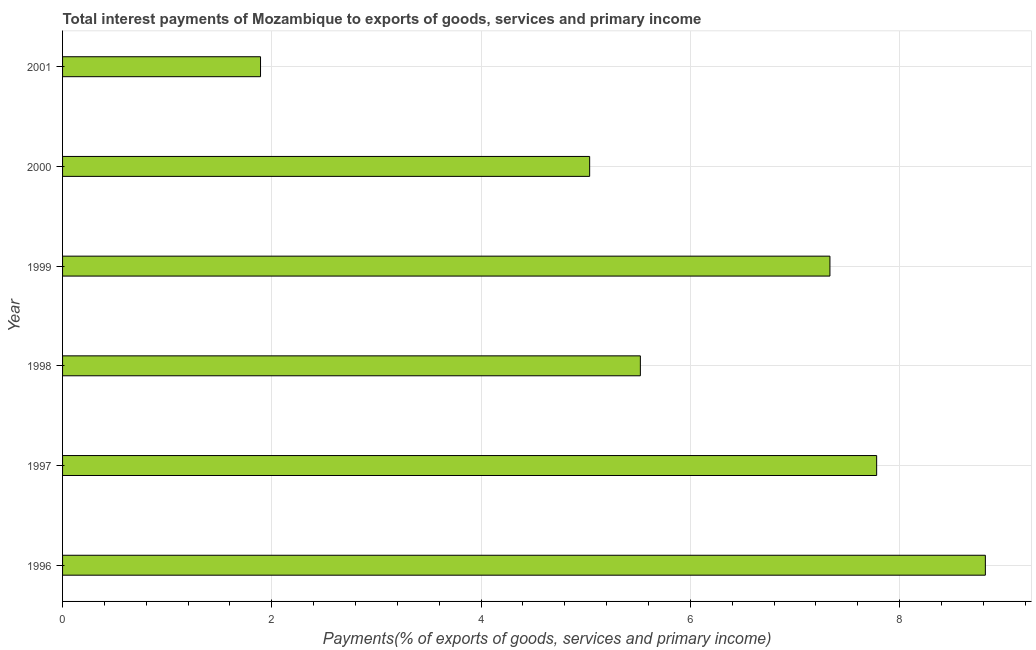Does the graph contain any zero values?
Offer a terse response. No. Does the graph contain grids?
Your answer should be compact. Yes. What is the title of the graph?
Offer a very short reply. Total interest payments of Mozambique to exports of goods, services and primary income. What is the label or title of the X-axis?
Offer a very short reply. Payments(% of exports of goods, services and primary income). What is the label or title of the Y-axis?
Make the answer very short. Year. What is the total interest payments on external debt in 2000?
Offer a terse response. 5.04. Across all years, what is the maximum total interest payments on external debt?
Your response must be concise. 8.82. Across all years, what is the minimum total interest payments on external debt?
Offer a terse response. 1.89. In which year was the total interest payments on external debt minimum?
Make the answer very short. 2001. What is the sum of the total interest payments on external debt?
Offer a very short reply. 36.38. What is the difference between the total interest payments on external debt in 1999 and 2000?
Give a very brief answer. 2.3. What is the average total interest payments on external debt per year?
Ensure brevity in your answer.  6.06. What is the median total interest payments on external debt?
Keep it short and to the point. 6.43. What is the ratio of the total interest payments on external debt in 2000 to that in 2001?
Keep it short and to the point. 2.66. Is the total interest payments on external debt in 1996 less than that in 2000?
Keep it short and to the point. No. What is the difference between the highest and the second highest total interest payments on external debt?
Offer a terse response. 1.04. Is the sum of the total interest payments on external debt in 1996 and 1997 greater than the maximum total interest payments on external debt across all years?
Provide a short and direct response. Yes. What is the difference between the highest and the lowest total interest payments on external debt?
Your response must be concise. 6.93. In how many years, is the total interest payments on external debt greater than the average total interest payments on external debt taken over all years?
Offer a terse response. 3. Are all the bars in the graph horizontal?
Your answer should be compact. Yes. What is the difference between two consecutive major ticks on the X-axis?
Your answer should be compact. 2. What is the Payments(% of exports of goods, services and primary income) of 1996?
Make the answer very short. 8.82. What is the Payments(% of exports of goods, services and primary income) of 1997?
Your answer should be compact. 7.78. What is the Payments(% of exports of goods, services and primary income) of 1998?
Offer a terse response. 5.52. What is the Payments(% of exports of goods, services and primary income) in 1999?
Make the answer very short. 7.33. What is the Payments(% of exports of goods, services and primary income) in 2000?
Your response must be concise. 5.04. What is the Payments(% of exports of goods, services and primary income) of 2001?
Make the answer very short. 1.89. What is the difference between the Payments(% of exports of goods, services and primary income) in 1996 and 1997?
Offer a very short reply. 1.04. What is the difference between the Payments(% of exports of goods, services and primary income) in 1996 and 1998?
Offer a terse response. 3.3. What is the difference between the Payments(% of exports of goods, services and primary income) in 1996 and 1999?
Your answer should be very brief. 1.49. What is the difference between the Payments(% of exports of goods, services and primary income) in 1996 and 2000?
Give a very brief answer. 3.78. What is the difference between the Payments(% of exports of goods, services and primary income) in 1996 and 2001?
Offer a very short reply. 6.93. What is the difference between the Payments(% of exports of goods, services and primary income) in 1997 and 1998?
Offer a terse response. 2.26. What is the difference between the Payments(% of exports of goods, services and primary income) in 1997 and 1999?
Make the answer very short. 0.45. What is the difference between the Payments(% of exports of goods, services and primary income) in 1997 and 2000?
Your answer should be very brief. 2.74. What is the difference between the Payments(% of exports of goods, services and primary income) in 1997 and 2001?
Your answer should be compact. 5.89. What is the difference between the Payments(% of exports of goods, services and primary income) in 1998 and 1999?
Offer a very short reply. -1.81. What is the difference between the Payments(% of exports of goods, services and primary income) in 1998 and 2000?
Ensure brevity in your answer.  0.48. What is the difference between the Payments(% of exports of goods, services and primary income) in 1998 and 2001?
Your answer should be compact. 3.63. What is the difference between the Payments(% of exports of goods, services and primary income) in 1999 and 2000?
Ensure brevity in your answer.  2.3. What is the difference between the Payments(% of exports of goods, services and primary income) in 1999 and 2001?
Your answer should be compact. 5.44. What is the difference between the Payments(% of exports of goods, services and primary income) in 2000 and 2001?
Offer a very short reply. 3.15. What is the ratio of the Payments(% of exports of goods, services and primary income) in 1996 to that in 1997?
Provide a short and direct response. 1.13. What is the ratio of the Payments(% of exports of goods, services and primary income) in 1996 to that in 1998?
Provide a short and direct response. 1.6. What is the ratio of the Payments(% of exports of goods, services and primary income) in 1996 to that in 1999?
Offer a terse response. 1.2. What is the ratio of the Payments(% of exports of goods, services and primary income) in 1996 to that in 2000?
Provide a short and direct response. 1.75. What is the ratio of the Payments(% of exports of goods, services and primary income) in 1996 to that in 2001?
Offer a very short reply. 4.66. What is the ratio of the Payments(% of exports of goods, services and primary income) in 1997 to that in 1998?
Offer a terse response. 1.41. What is the ratio of the Payments(% of exports of goods, services and primary income) in 1997 to that in 1999?
Make the answer very short. 1.06. What is the ratio of the Payments(% of exports of goods, services and primary income) in 1997 to that in 2000?
Give a very brief answer. 1.54. What is the ratio of the Payments(% of exports of goods, services and primary income) in 1997 to that in 2001?
Your response must be concise. 4.11. What is the ratio of the Payments(% of exports of goods, services and primary income) in 1998 to that in 1999?
Make the answer very short. 0.75. What is the ratio of the Payments(% of exports of goods, services and primary income) in 1998 to that in 2000?
Ensure brevity in your answer.  1.1. What is the ratio of the Payments(% of exports of goods, services and primary income) in 1998 to that in 2001?
Offer a very short reply. 2.92. What is the ratio of the Payments(% of exports of goods, services and primary income) in 1999 to that in 2000?
Your response must be concise. 1.46. What is the ratio of the Payments(% of exports of goods, services and primary income) in 1999 to that in 2001?
Keep it short and to the point. 3.88. What is the ratio of the Payments(% of exports of goods, services and primary income) in 2000 to that in 2001?
Keep it short and to the point. 2.66. 